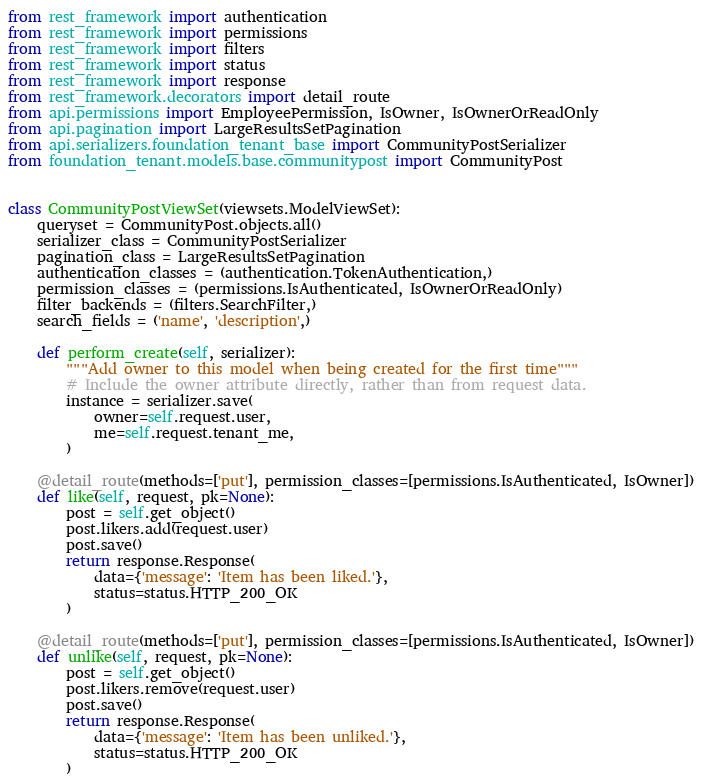Convert code to text. <code><loc_0><loc_0><loc_500><loc_500><_Python_>from rest_framework import authentication
from rest_framework import permissions
from rest_framework import filters
from rest_framework import status
from rest_framework import response
from rest_framework.decorators import detail_route
from api.permissions import EmployeePermission, IsOwner, IsOwnerOrReadOnly
from api.pagination import LargeResultsSetPagination
from api.serializers.foundation_tenant_base import CommunityPostSerializer
from foundation_tenant.models.base.communitypost import CommunityPost


class CommunityPostViewSet(viewsets.ModelViewSet):
    queryset = CommunityPost.objects.all()
    serializer_class = CommunityPostSerializer
    pagination_class = LargeResultsSetPagination
    authentication_classes = (authentication.TokenAuthentication,)
    permission_classes = (permissions.IsAuthenticated, IsOwnerOrReadOnly)
    filter_backends = (filters.SearchFilter,)
    search_fields = ('name', 'description',)

    def perform_create(self, serializer):
        """Add owner to this model when being created for the first time"""
        # Include the owner attribute directly, rather than from request data.
        instance = serializer.save(
            owner=self.request.user,
            me=self.request.tenant_me,
        )

    @detail_route(methods=['put'], permission_classes=[permissions.IsAuthenticated, IsOwner])
    def like(self, request, pk=None):
        post = self.get_object()
        post.likers.add(request.user)
        post.save()
        return response.Response(
            data={'message': 'Item has been liked.'},
            status=status.HTTP_200_OK
        )

    @detail_route(methods=['put'], permission_classes=[permissions.IsAuthenticated, IsOwner])
    def unlike(self, request, pk=None):
        post = self.get_object()
        post.likers.remove(request.user)
        post.save()
        return response.Response(
            data={'message': 'Item has been unliked.'},
            status=status.HTTP_200_OK
        )
</code> 